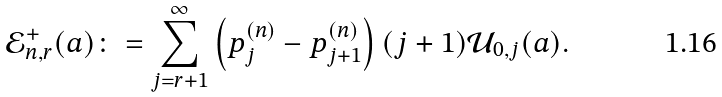Convert formula to latex. <formula><loc_0><loc_0><loc_500><loc_500>\mathcal { E } _ { n , r } ^ { + } ( a ) \colon = \sum _ { j = r + 1 } ^ { \infty } \left ( p ^ { ( n ) } _ { j } - p ^ { ( n ) } _ { j + 1 } \right ) ( j + 1 ) \mathcal { U } _ { 0 , j } ( a ) .</formula> 